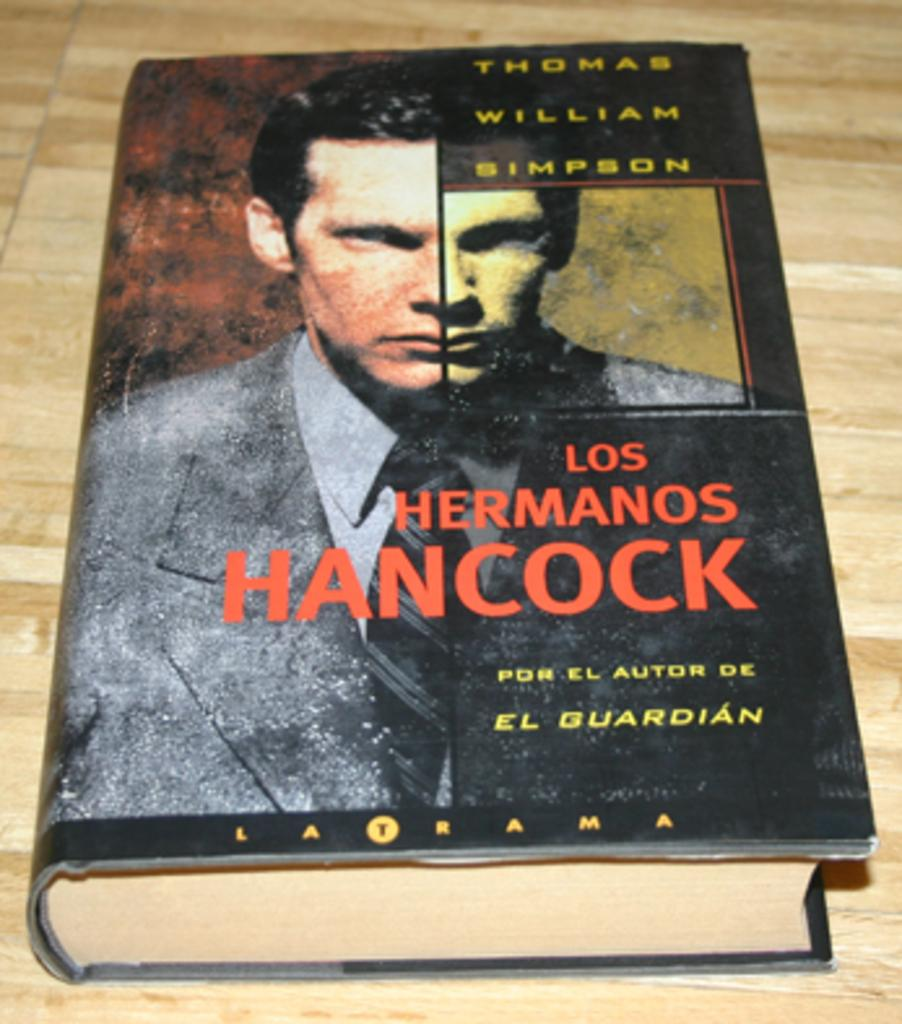<image>
Relay a brief, clear account of the picture shown. a book that says 'los hermanos hancock' on it 